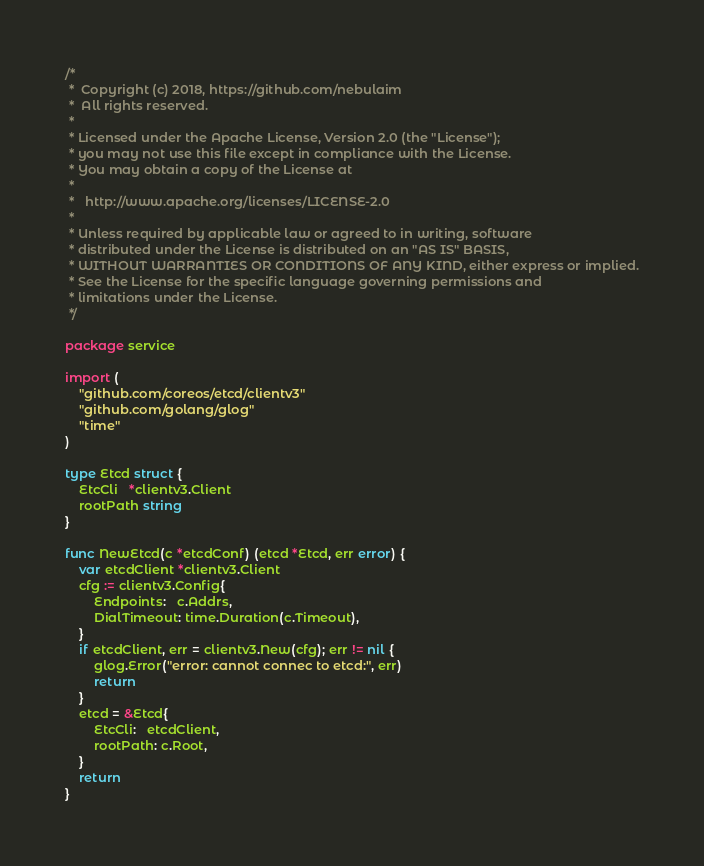Convert code to text. <code><loc_0><loc_0><loc_500><loc_500><_Go_>/*
 *  Copyright (c) 2018, https://github.com/nebulaim
 *  All rights reserved.
 *
 * Licensed under the Apache License, Version 2.0 (the "License");
 * you may not use this file except in compliance with the License.
 * You may obtain a copy of the License at
 *
 *   http://www.apache.org/licenses/LICENSE-2.0
 *
 * Unless required by applicable law or agreed to in writing, software
 * distributed under the License is distributed on an "AS IS" BASIS,
 * WITHOUT WARRANTIES OR CONDITIONS OF ANY KIND, either express or implied.
 * See the License for the specific language governing permissions and
 * limitations under the License.
 */

package service

import (
	"github.com/coreos/etcd/clientv3"
	"github.com/golang/glog"
	"time"
)

type Etcd struct {
	EtcCli   *clientv3.Client
	rootPath string
}

func NewEtcd(c *etcdConf) (etcd *Etcd, err error) {
	var etcdClient *clientv3.Client
	cfg := clientv3.Config{
		Endpoints:   c.Addrs,
		DialTimeout: time.Duration(c.Timeout),
	}
	if etcdClient, err = clientv3.New(cfg); err != nil {
		glog.Error("error: cannot connec to etcd:", err)
		return
	}
	etcd = &Etcd{
		EtcCli:   etcdClient,
		rootPath: c.Root,
	}
	return
}
</code> 